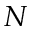<formula> <loc_0><loc_0><loc_500><loc_500>N</formula> 